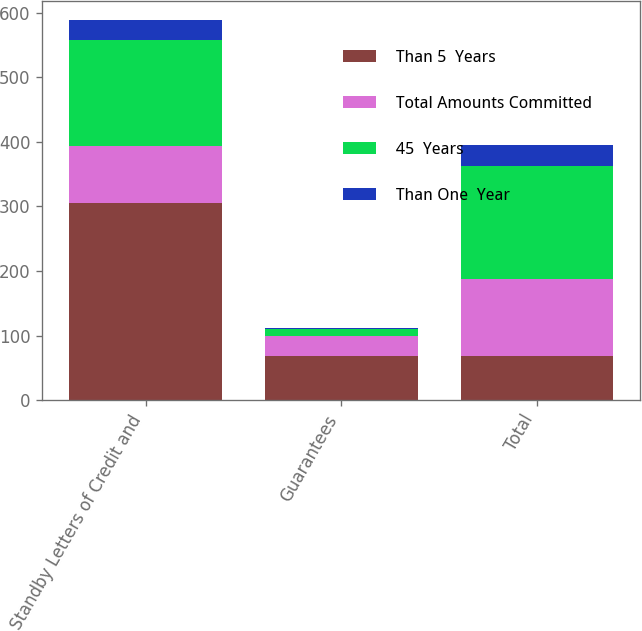Convert chart. <chart><loc_0><loc_0><loc_500><loc_500><stacked_bar_chart><ecel><fcel>Standby Letters of Credit and<fcel>Guarantees<fcel>Total<nl><fcel>Than 5  Years<fcel>305.2<fcel>68.7<fcel>68.7<nl><fcel>Total Amounts Committed<fcel>88.4<fcel>30.3<fcel>118.7<nl><fcel>45  Years<fcel>164.8<fcel>10.7<fcel>175.5<nl><fcel>Than One  Year<fcel>29.9<fcel>2<fcel>31.9<nl></chart> 